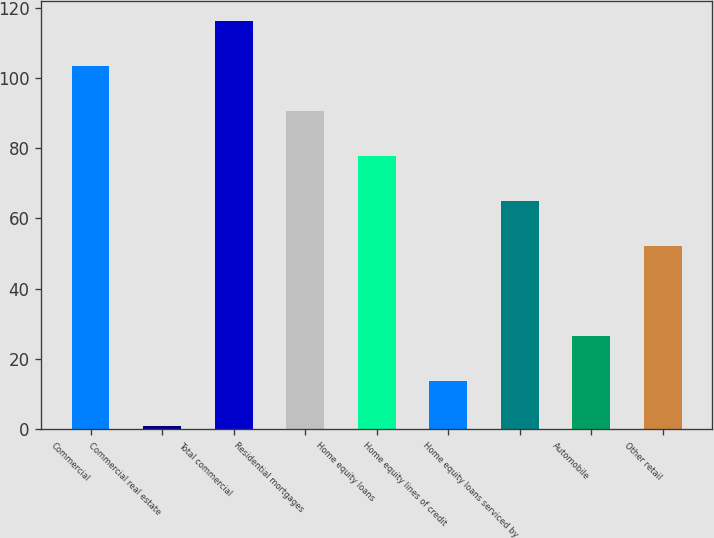<chart> <loc_0><loc_0><loc_500><loc_500><bar_chart><fcel>Commercial<fcel>Commercial real estate<fcel>Total commercial<fcel>Residential mortgages<fcel>Home equity loans<fcel>Home equity lines of credit<fcel>Home equity loans serviced by<fcel>Automobile<fcel>Other retail<nl><fcel>103.4<fcel>1<fcel>116.2<fcel>90.6<fcel>77.8<fcel>13.8<fcel>65<fcel>26.6<fcel>52.2<nl></chart> 